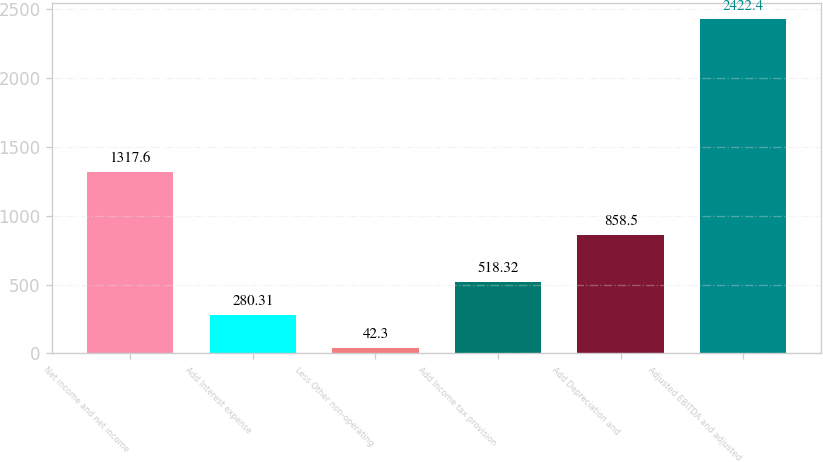Convert chart. <chart><loc_0><loc_0><loc_500><loc_500><bar_chart><fcel>Net income and net income<fcel>Add Interest expense<fcel>Less Other non-operating<fcel>Add Income tax provision<fcel>Add Depreciation and<fcel>Adjusted EBITDA and adjusted<nl><fcel>1317.6<fcel>280.31<fcel>42.3<fcel>518.32<fcel>858.5<fcel>2422.4<nl></chart> 